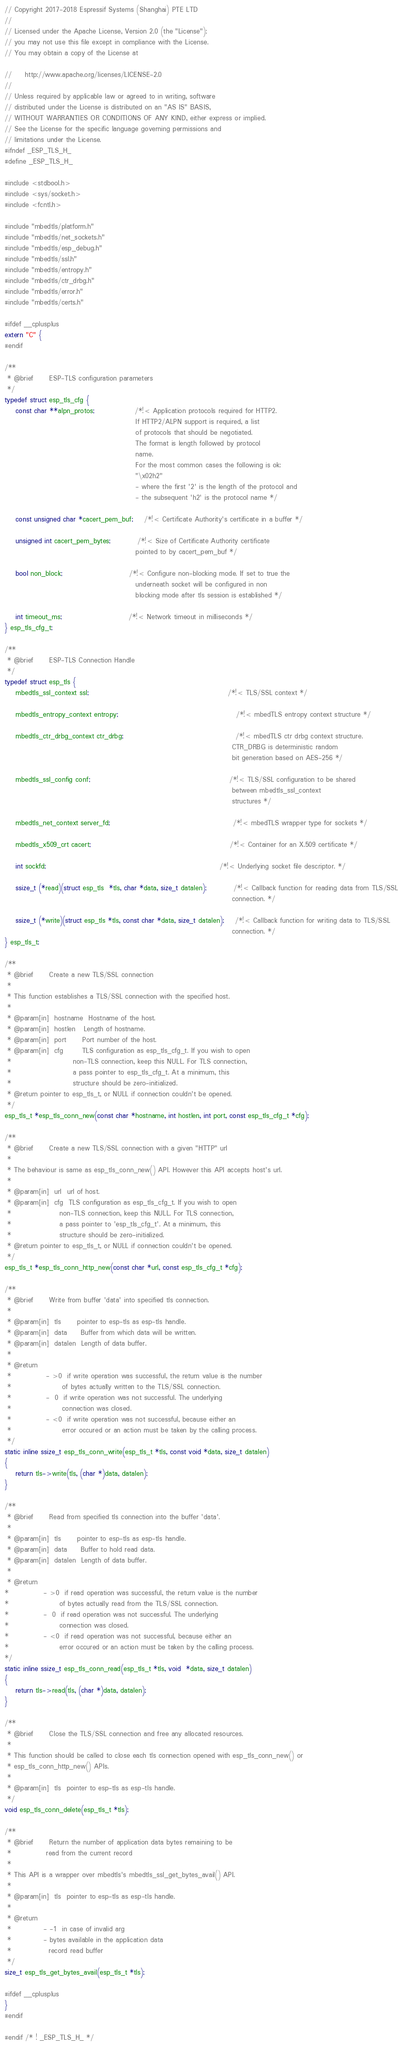<code> <loc_0><loc_0><loc_500><loc_500><_C_>// Copyright 2017-2018 Espressif Systems (Shanghai) PTE LTD
//
// Licensed under the Apache License, Version 2.0 (the "License");
// you may not use this file except in compliance with the License.
// You may obtain a copy of the License at

//     http://www.apache.org/licenses/LICENSE-2.0
//
// Unless required by applicable law or agreed to in writing, software
// distributed under the License is distributed on an "AS IS" BASIS,
// WITHOUT WARRANTIES OR CONDITIONS OF ANY KIND, either express or implied.
// See the License for the specific language governing permissions and
// limitations under the License.
#ifndef _ESP_TLS_H_
#define _ESP_TLS_H_

#include <stdbool.h>
#include <sys/socket.h>
#include <fcntl.h>

#include "mbedtls/platform.h"
#include "mbedtls/net_sockets.h"
#include "mbedtls/esp_debug.h"
#include "mbedtls/ssl.h"
#include "mbedtls/entropy.h"
#include "mbedtls/ctr_drbg.h"
#include "mbedtls/error.h"
#include "mbedtls/certs.h"

#ifdef __cplusplus
extern "C" {
#endif

/**
 * @brief      ESP-TLS configuration parameters 
 */ 
typedef struct esp_tls_cfg {
    const char **alpn_protos;               /*!< Application protocols required for HTTP2.
                                                 If HTTP2/ALPN support is required, a list
                                                 of protocols that should be negotiated. 
                                                 The format is length followed by protocol
                                                 name. 
                                                 For the most common cases the following is ok:
                                                 "\x02h2"
                                                 - where the first '2' is the length of the protocol and
                                                 - the subsequent 'h2' is the protocol name */
 
    const unsigned char *cacert_pem_buf;    /*!< Certificate Authority's certificate in a buffer */
 
    unsigned int cacert_pem_bytes;          /*!< Size of Certificate Authority certificate
                                                 pointed to by cacert_pem_buf */
 
    bool non_block;                         /*!< Configure non-blocking mode. If set to true the 
                                                 underneath socket will be configured in non 
                                                 blocking mode after tls session is established */

    int timeout_ms;                         /*!< Network timeout in milliseconds */
} esp_tls_cfg_t;

/**
 * @brief      ESP-TLS Connection Handle 
 */
typedef struct esp_tls {
    mbedtls_ssl_context ssl;                                                    /*!< TLS/SSL context */
 
    mbedtls_entropy_context entropy;                                            /*!< mbedTLS entropy context structure */
 
    mbedtls_ctr_drbg_context ctr_drbg;                                          /*!< mbedTLS ctr drbg context structure.
                                                                                     CTR_DRBG is deterministic random 
                                                                                     bit generation based on AES-256 */
 
    mbedtls_ssl_config conf;                                                    /*!< TLS/SSL configuration to be shared 
                                                                                     between mbedtls_ssl_context 
                                                                                     structures */
 
    mbedtls_net_context server_fd;                                              /*!< mbedTLS wrapper type for sockets */
 
    mbedtls_x509_crt cacert;                                                    /*!< Container for an X.509 certificate */
 
    int sockfd;                                                                 /*!< Underlying socket file descriptor. */
 
    ssize_t (*read)(struct esp_tls  *tls, char *data, size_t datalen);          /*!< Callback function for reading data from TLS/SSL
                                                                                     connection. */
 
    ssize_t (*write)(struct esp_tls *tls, const char *data, size_t datalen);    /*!< Callback function for writing data to TLS/SSL
                                                                                     connection. */
} esp_tls_t;

/**
 * @brief      Create a new TLS/SSL connection
 *
 * This function establishes a TLS/SSL connection with the specified host.
 * 
 * @param[in]  hostname  Hostname of the host.
 * @param[in]  hostlen   Length of hostname.
 * @param[in]  port      Port number of the host.
 * @param[in]  cfg       TLS configuration as esp_tls_cfg_t. If you wish to open 
 *                       non-TLS connection, keep this NULL. For TLS connection,
 *                       a pass pointer to esp_tls_cfg_t. At a minimum, this
 *                       structure should be zero-initialized.
 * @return pointer to esp_tls_t, or NULL if connection couldn't be opened.
 */
esp_tls_t *esp_tls_conn_new(const char *hostname, int hostlen, int port, const esp_tls_cfg_t *cfg);

/**
 * @brief      Create a new TLS/SSL connection with a given "HTTP" url    
 *
 * The behaviour is same as esp_tls_conn_new() API. However this API accepts host's url.
 * 
 * @param[in]  url  url of host.
 * @param[in]  cfg  TLS configuration as esp_tls_cfg_t. If you wish to open
 *                  non-TLS connection, keep this NULL. For TLS connection,
 *                  a pass pointer to 'esp_tls_cfg_t'. At a minimum, this
 *                  structure should be zero-initialized.
 * @return pointer to esp_tls_t, or NULL if connection couldn't be opened.
 */
esp_tls_t *esp_tls_conn_http_new(const char *url, const esp_tls_cfg_t *cfg);
   
/**
 * @brief      Write from buffer 'data' into specified tls connection.
 * 
 * @param[in]  tls      pointer to esp-tls as esp-tls handle.
 * @param[in]  data     Buffer from which data will be written.
 * @param[in]  datalen  Length of data buffer.
 * 
 * @return 
 *             - >0  if write operation was successful, the return value is the number 
 *                   of bytes actually written to the TLS/SSL connection.  
 *             -  0  if write operation was not successful. The underlying
 *                   connection was closed.
 *             - <0  if write operation was not successful, because either an 
 *                   error occured or an action must be taken by the calling process.   
 */
static inline ssize_t esp_tls_conn_write(esp_tls_t *tls, const void *data, size_t datalen)
{
    return tls->write(tls, (char *)data, datalen);
}

/**
 * @brief      Read from specified tls connection into the buffer 'data'.
 * 
 * @param[in]  tls      pointer to esp-tls as esp-tls handle.
 * @param[in]  data     Buffer to hold read data.
 * @param[in]  datalen  Length of data buffer. 
 *
 * @return
*             - >0  if read operation was successful, the return value is the number
*                   of bytes actually read from the TLS/SSL connection.
*             -  0  if read operation was not successful. The underlying
*                   connection was closed.
*             - <0  if read operation was not successful, because either an
*                   error occured or an action must be taken by the calling process.
*/
static inline ssize_t esp_tls_conn_read(esp_tls_t *tls, void  *data, size_t datalen)
{
    return tls->read(tls, (char *)data, datalen);
}

/**
 * @brief      Close the TLS/SSL connection and free any allocated resources.
 * 
 * This function should be called to close each tls connection opened with esp_tls_conn_new() or
 * esp_tls_conn_http_new() APIs. 
 *
 * @param[in]  tls  pointer to esp-tls as esp-tls handle.    
 */
void esp_tls_conn_delete(esp_tls_t *tls);

/**
 * @brief      Return the number of application data bytes remaining to be
 *             read from the current record
 *
 * This API is a wrapper over mbedtls's mbedtls_ssl_get_bytes_avail() API.
 *
 * @param[in]  tls  pointer to esp-tls as esp-tls handle.
 *
 * @return
 *            - -1  in case of invalid arg
 *            - bytes available in the application data
 *              record read buffer
 */
size_t esp_tls_get_bytes_avail(esp_tls_t *tls);

#ifdef __cplusplus
}
#endif

#endif /* ! _ESP_TLS_H_ */
</code> 